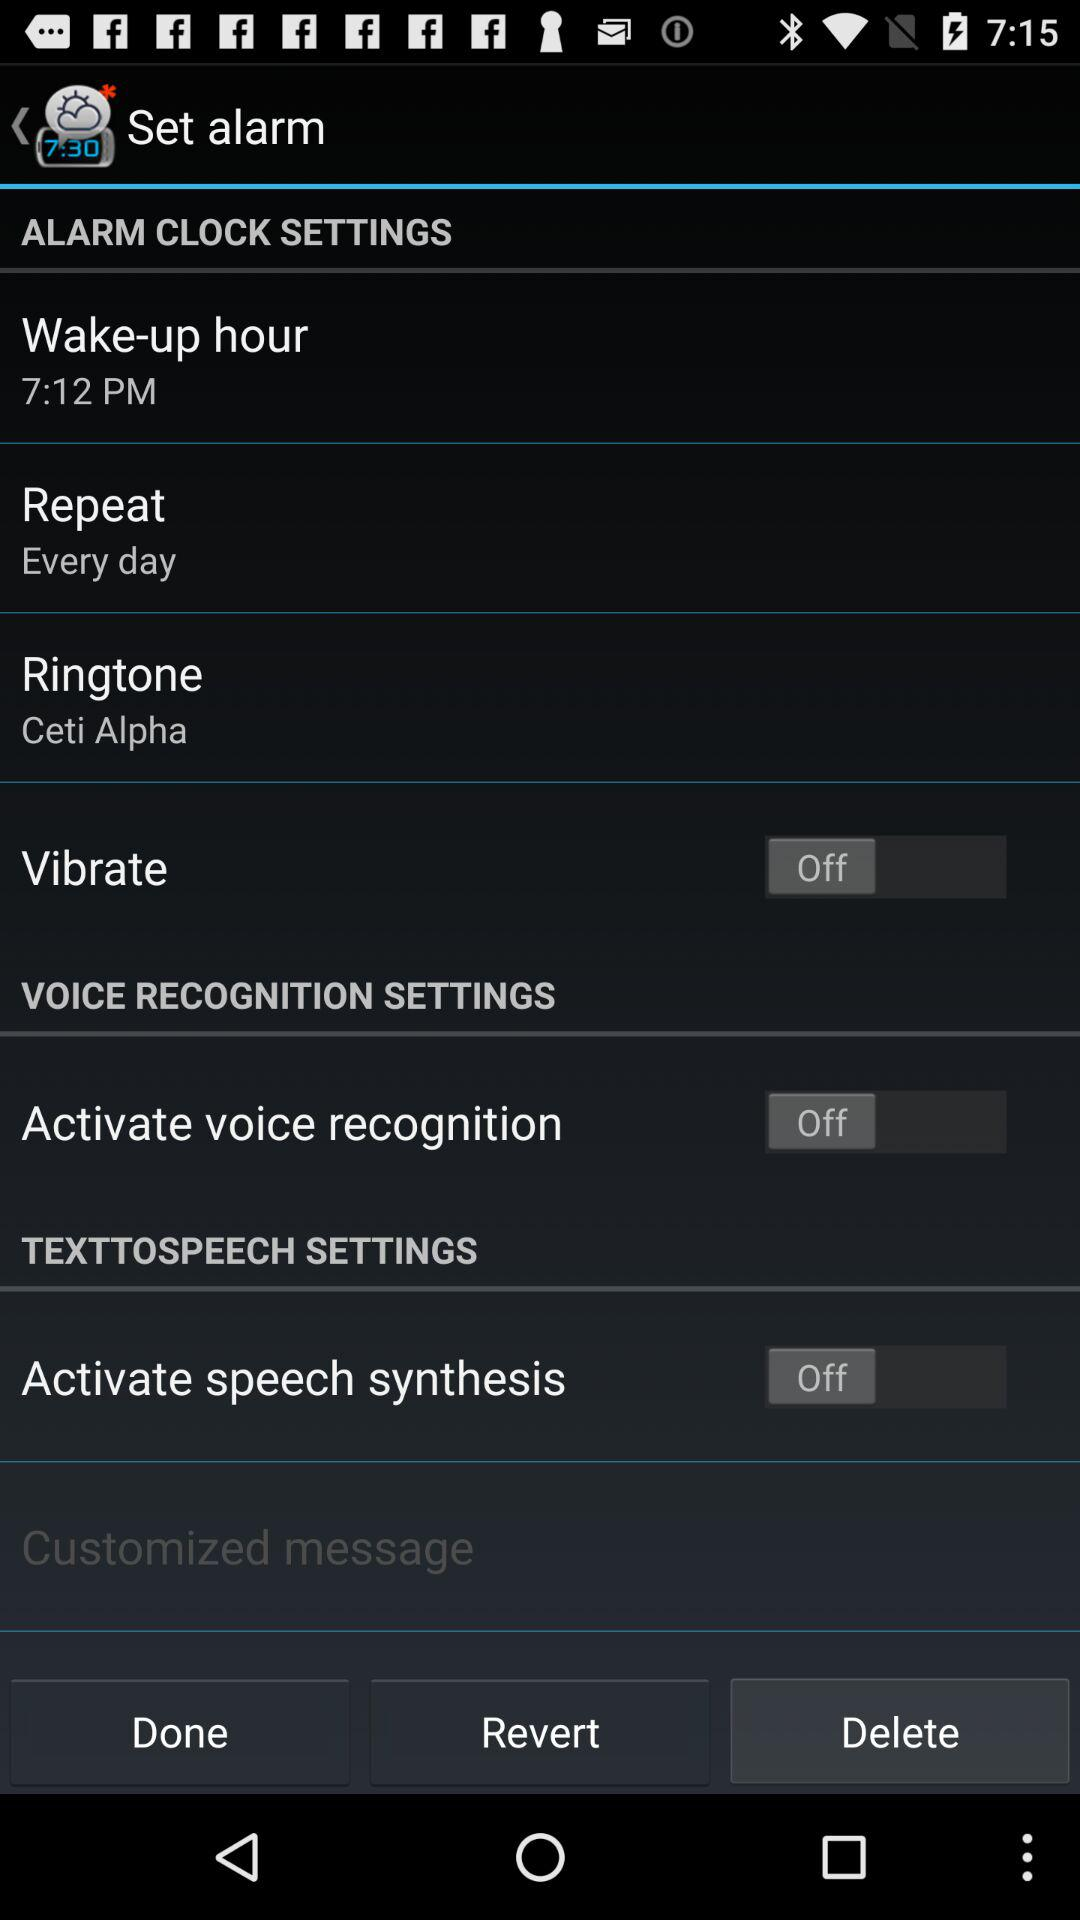What is the selected ringtone? The selected ringtone is "Ceti Alpha". 